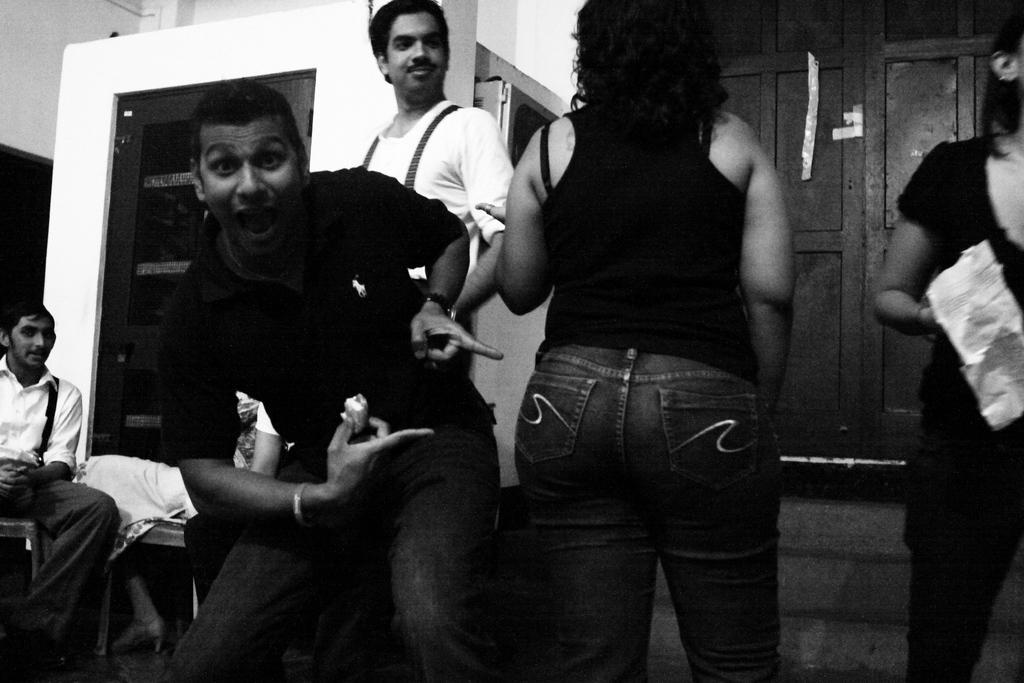How would you summarize this image in a sentence or two? In this image, we can see persons wearing clothes. There are steps in the bottom right of the image. There is a door on the right side of the image. There are two persons on the left side of the image sitting on chairs. 